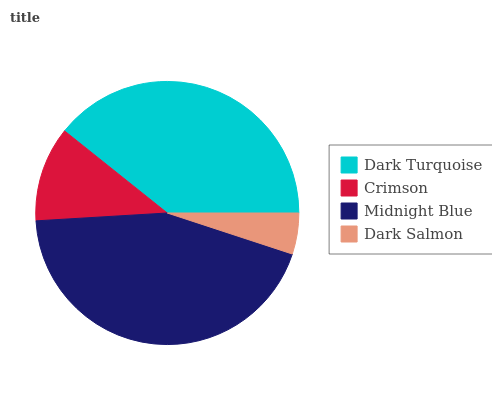Is Dark Salmon the minimum?
Answer yes or no. Yes. Is Midnight Blue the maximum?
Answer yes or no. Yes. Is Crimson the minimum?
Answer yes or no. No. Is Crimson the maximum?
Answer yes or no. No. Is Dark Turquoise greater than Crimson?
Answer yes or no. Yes. Is Crimson less than Dark Turquoise?
Answer yes or no. Yes. Is Crimson greater than Dark Turquoise?
Answer yes or no. No. Is Dark Turquoise less than Crimson?
Answer yes or no. No. Is Dark Turquoise the high median?
Answer yes or no. Yes. Is Crimson the low median?
Answer yes or no. Yes. Is Dark Salmon the high median?
Answer yes or no. No. Is Dark Turquoise the low median?
Answer yes or no. No. 